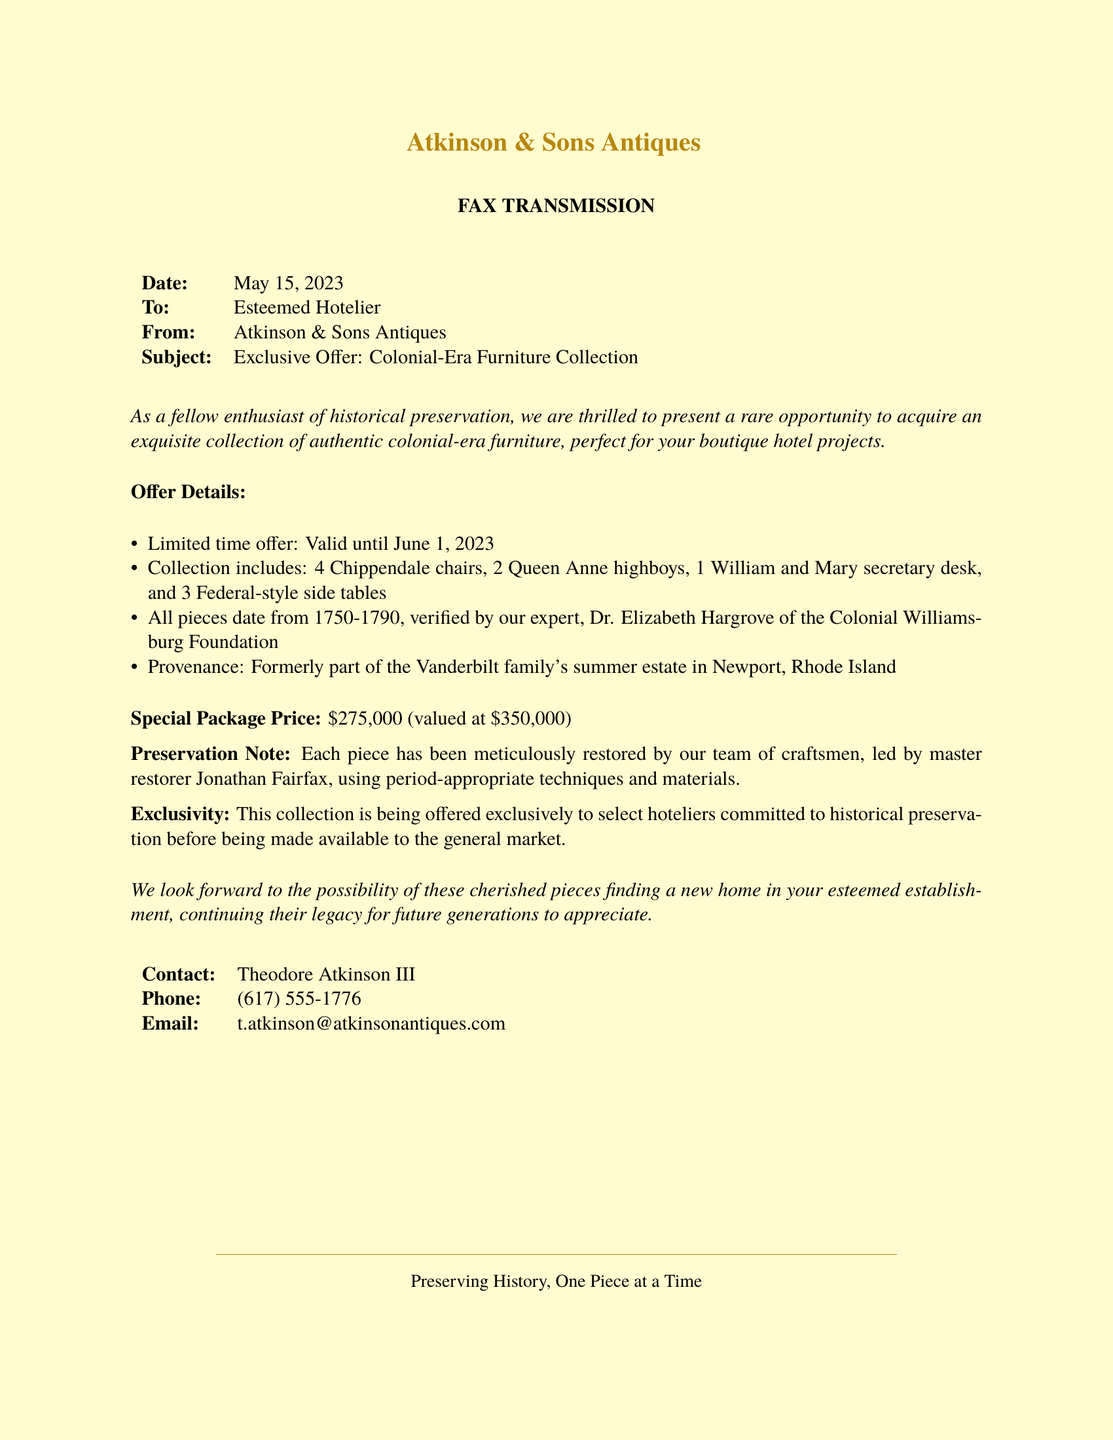What is the date of the fax? The date of the fax is specified in the document under the "Date" section.
Answer: May 15, 2023 What furniture pieces are included in the collection? The collection includes several specific furniture pieces listed under "Offer Details."
Answer: 4 Chippendale chairs, 2 Queen Anne highboys, 1 William and Mary secretary desk, and 3 Federal-style side tables What is the special package price? The special package price is clearly stated in the document.
Answer: \$275,000 Who verified the authenticity of the furniture pieces? The document mentions an expert who verified the authenticity of the pieces.
Answer: Dr. Elizabeth Hargrove What is the provenance of the furniture collection? The provenance section lists the previous ownership of the collection.
Answer: Formerly part of the Vanderbilt family's summer estate in Newport, Rhode Island What is the validity period of the offer? The document provides a specific date range for the offer's validity.
Answer: Until June 1, 2023 Who is the contact person for this offer? The document includes the name of the person to contact for more information.
Answer: Theodore Atkinson III What preservation technique was used on the furniture? The preservation note in the document mentions the qualifications of the team that restored the pieces.
Answer: Period-appropriate techniques and materials 